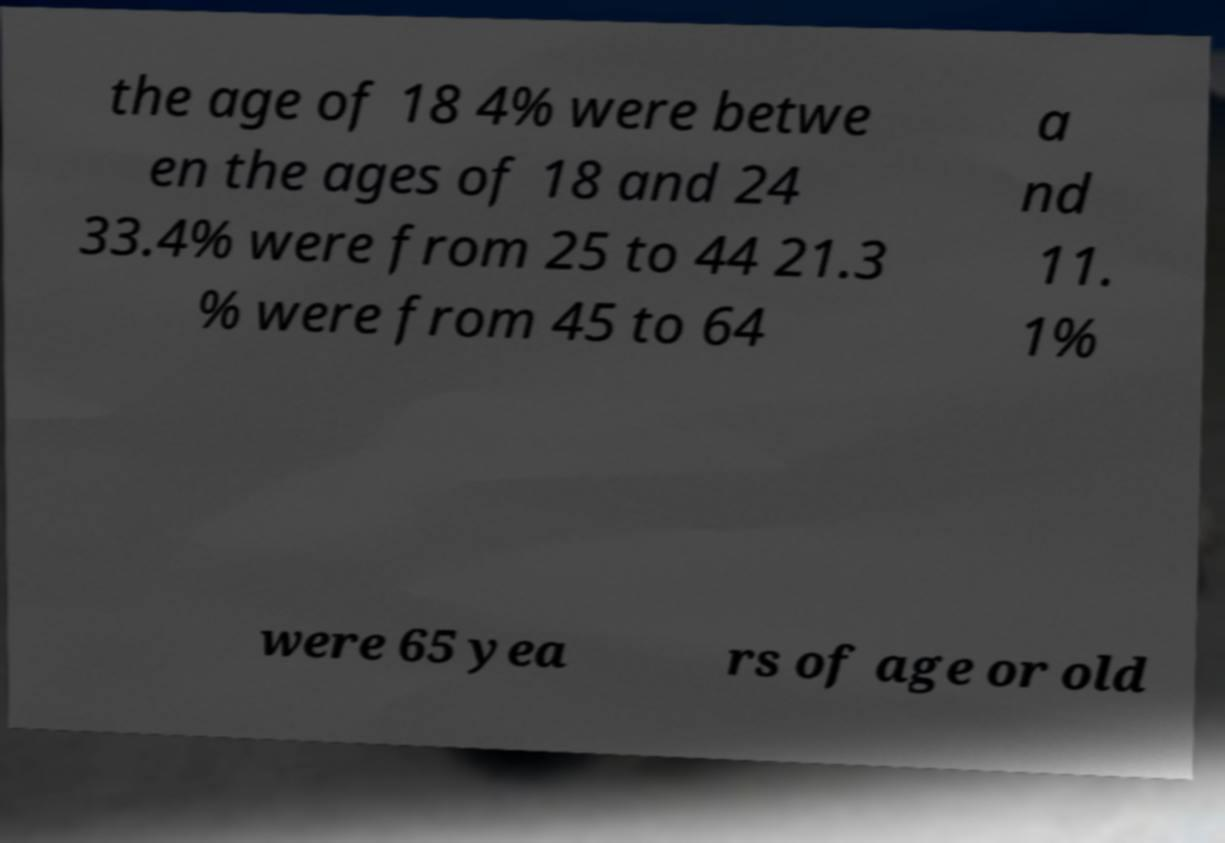I need the written content from this picture converted into text. Can you do that? the age of 18 4% were betwe en the ages of 18 and 24 33.4% were from 25 to 44 21.3 % were from 45 to 64 a nd 11. 1% were 65 yea rs of age or old 